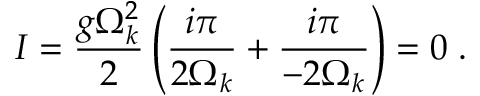Convert formula to latex. <formula><loc_0><loc_0><loc_500><loc_500>I = \frac { g \Omega _ { k } ^ { 2 } } { 2 } \left ( \frac { i \pi } { 2 \Omega _ { k } } + \frac { i \pi } { - 2 \Omega _ { k } } \right ) = 0 \, .</formula> 